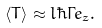Convert formula to latex. <formula><loc_0><loc_0><loc_500><loc_500>\langle { T } \rangle \approx l \hbar { \Gamma } { e } _ { z } .</formula> 